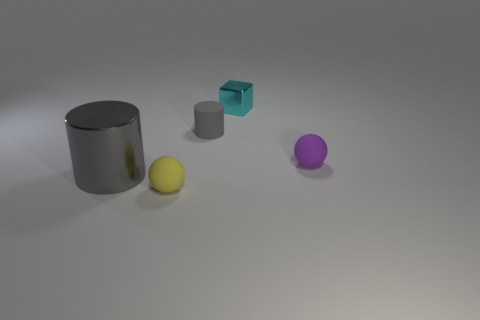Add 4 shiny things. How many objects exist? 9 Subtract 0 blue cylinders. How many objects are left? 5 Subtract all cylinders. How many objects are left? 3 Subtract all small blue spheres. Subtract all spheres. How many objects are left? 3 Add 5 tiny things. How many tiny things are left? 9 Add 5 large gray cylinders. How many large gray cylinders exist? 6 